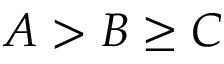<formula> <loc_0><loc_0><loc_500><loc_500>A > B \geq C</formula> 